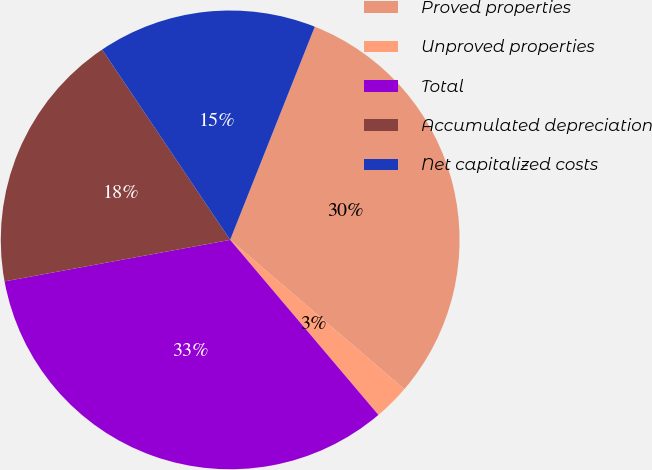Convert chart to OTSL. <chart><loc_0><loc_0><loc_500><loc_500><pie_chart><fcel>Proved properties<fcel>Unproved properties<fcel>Total<fcel>Accumulated depreciation<fcel>Net capitalized costs<nl><fcel>30.26%<fcel>2.54%<fcel>33.29%<fcel>18.47%<fcel>15.44%<nl></chart> 